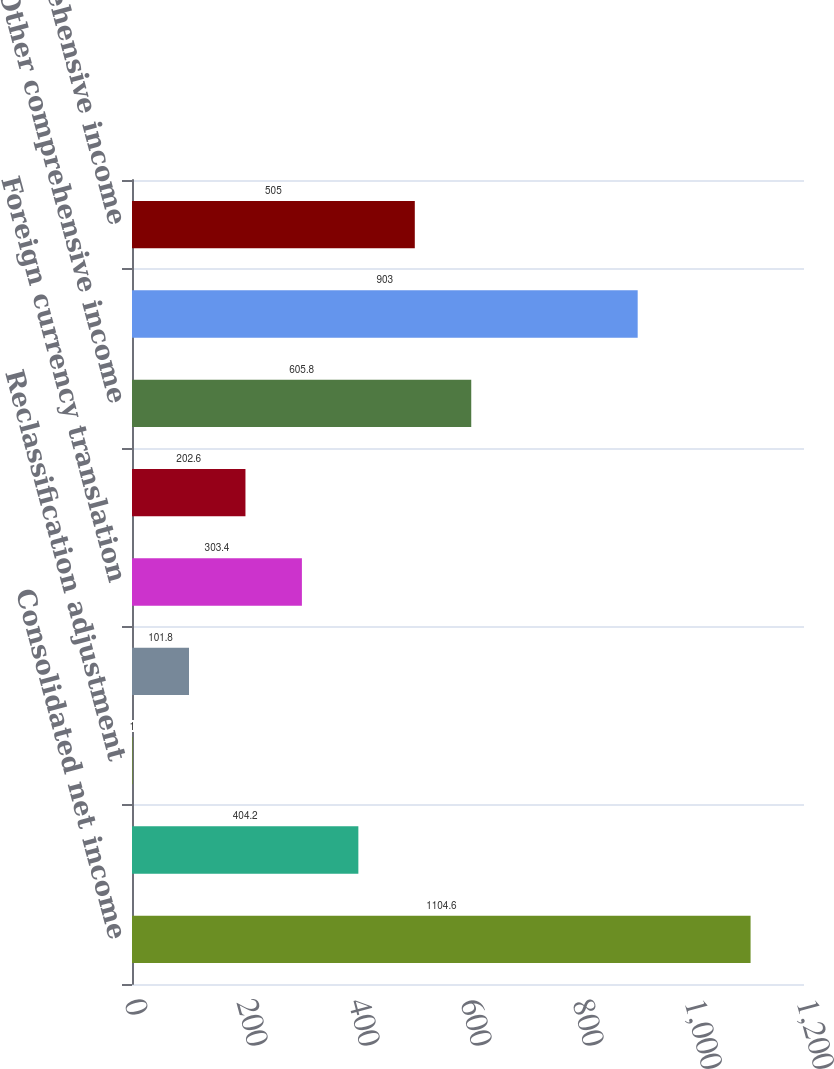Convert chart. <chart><loc_0><loc_0><loc_500><loc_500><bar_chart><fcel>Consolidated net income<fcel>Unrealized gains (losses)<fcel>Reclassification adjustment<fcel>Unrealized gains (losses) on<fcel>Foreign currency translation<fcel>Change in funded status of<fcel>Other comprehensive income<fcel>Comprehensive income<fcel>Less Comprehensive income<nl><fcel>1104.6<fcel>404.2<fcel>1<fcel>101.8<fcel>303.4<fcel>202.6<fcel>605.8<fcel>903<fcel>505<nl></chart> 